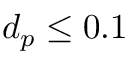Convert formula to latex. <formula><loc_0><loc_0><loc_500><loc_500>d _ { p } \leq 0 . 1</formula> 